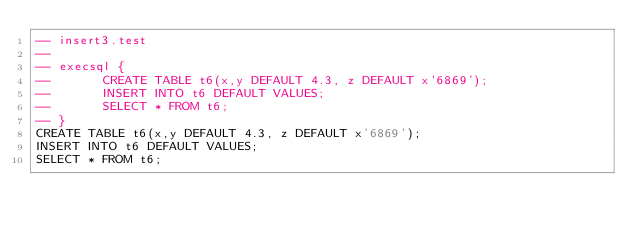Convert code to text. <code><loc_0><loc_0><loc_500><loc_500><_SQL_>-- insert3.test
-- 
-- execsql {
--       CREATE TABLE t6(x,y DEFAULT 4.3, z DEFAULT x'6869');
--       INSERT INTO t6 DEFAULT VALUES;
--       SELECT * FROM t6;
-- }
CREATE TABLE t6(x,y DEFAULT 4.3, z DEFAULT x'6869');
INSERT INTO t6 DEFAULT VALUES;
SELECT * FROM t6;</code> 